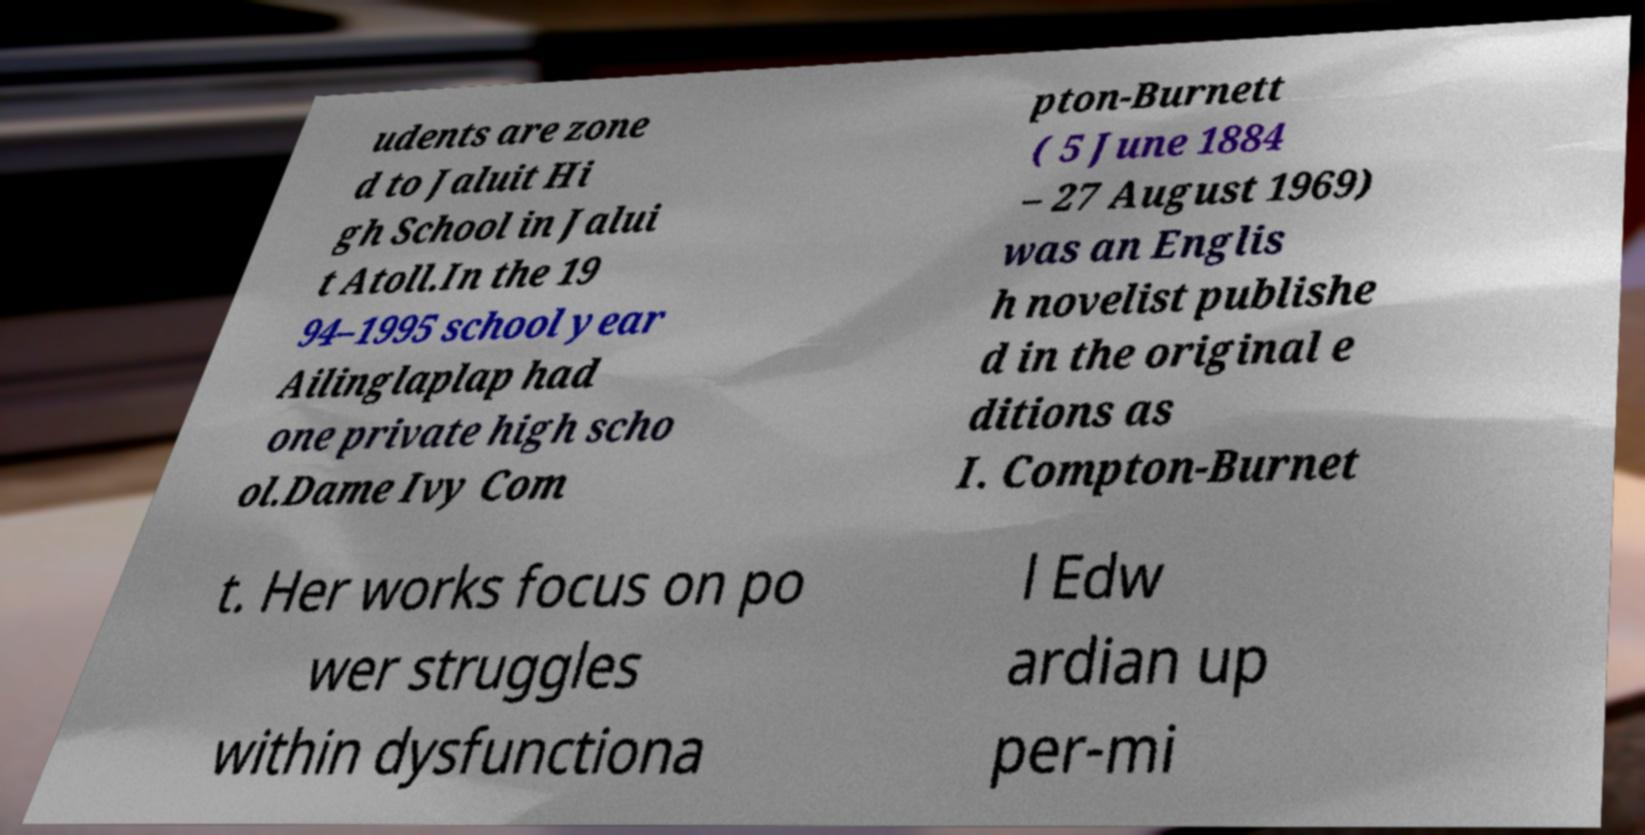Please read and relay the text visible in this image. What does it say? udents are zone d to Jaluit Hi gh School in Jalui t Atoll.In the 19 94–1995 school year Ailinglaplap had one private high scho ol.Dame Ivy Com pton-Burnett ( 5 June 1884 – 27 August 1969) was an Englis h novelist publishe d in the original e ditions as I. Compton-Burnet t. Her works focus on po wer struggles within dysfunctiona l Edw ardian up per-mi 